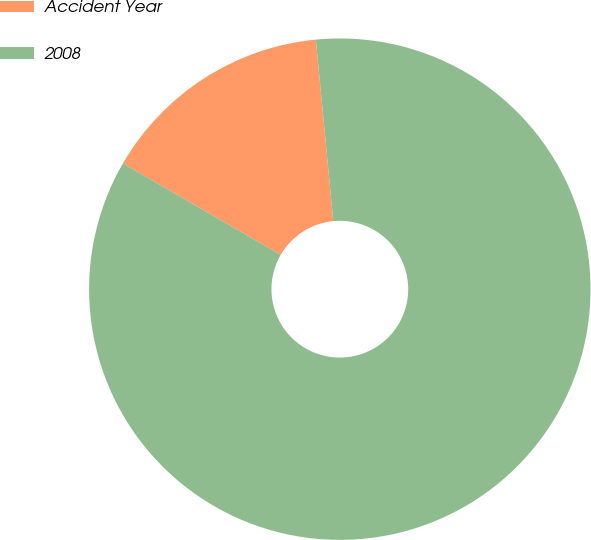Convert chart to OTSL. <chart><loc_0><loc_0><loc_500><loc_500><pie_chart><fcel>Accident Year<fcel>2008<nl><fcel>15.11%<fcel>84.89%<nl></chart> 